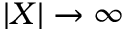<formula> <loc_0><loc_0><loc_500><loc_500>| X | \to \infty</formula> 